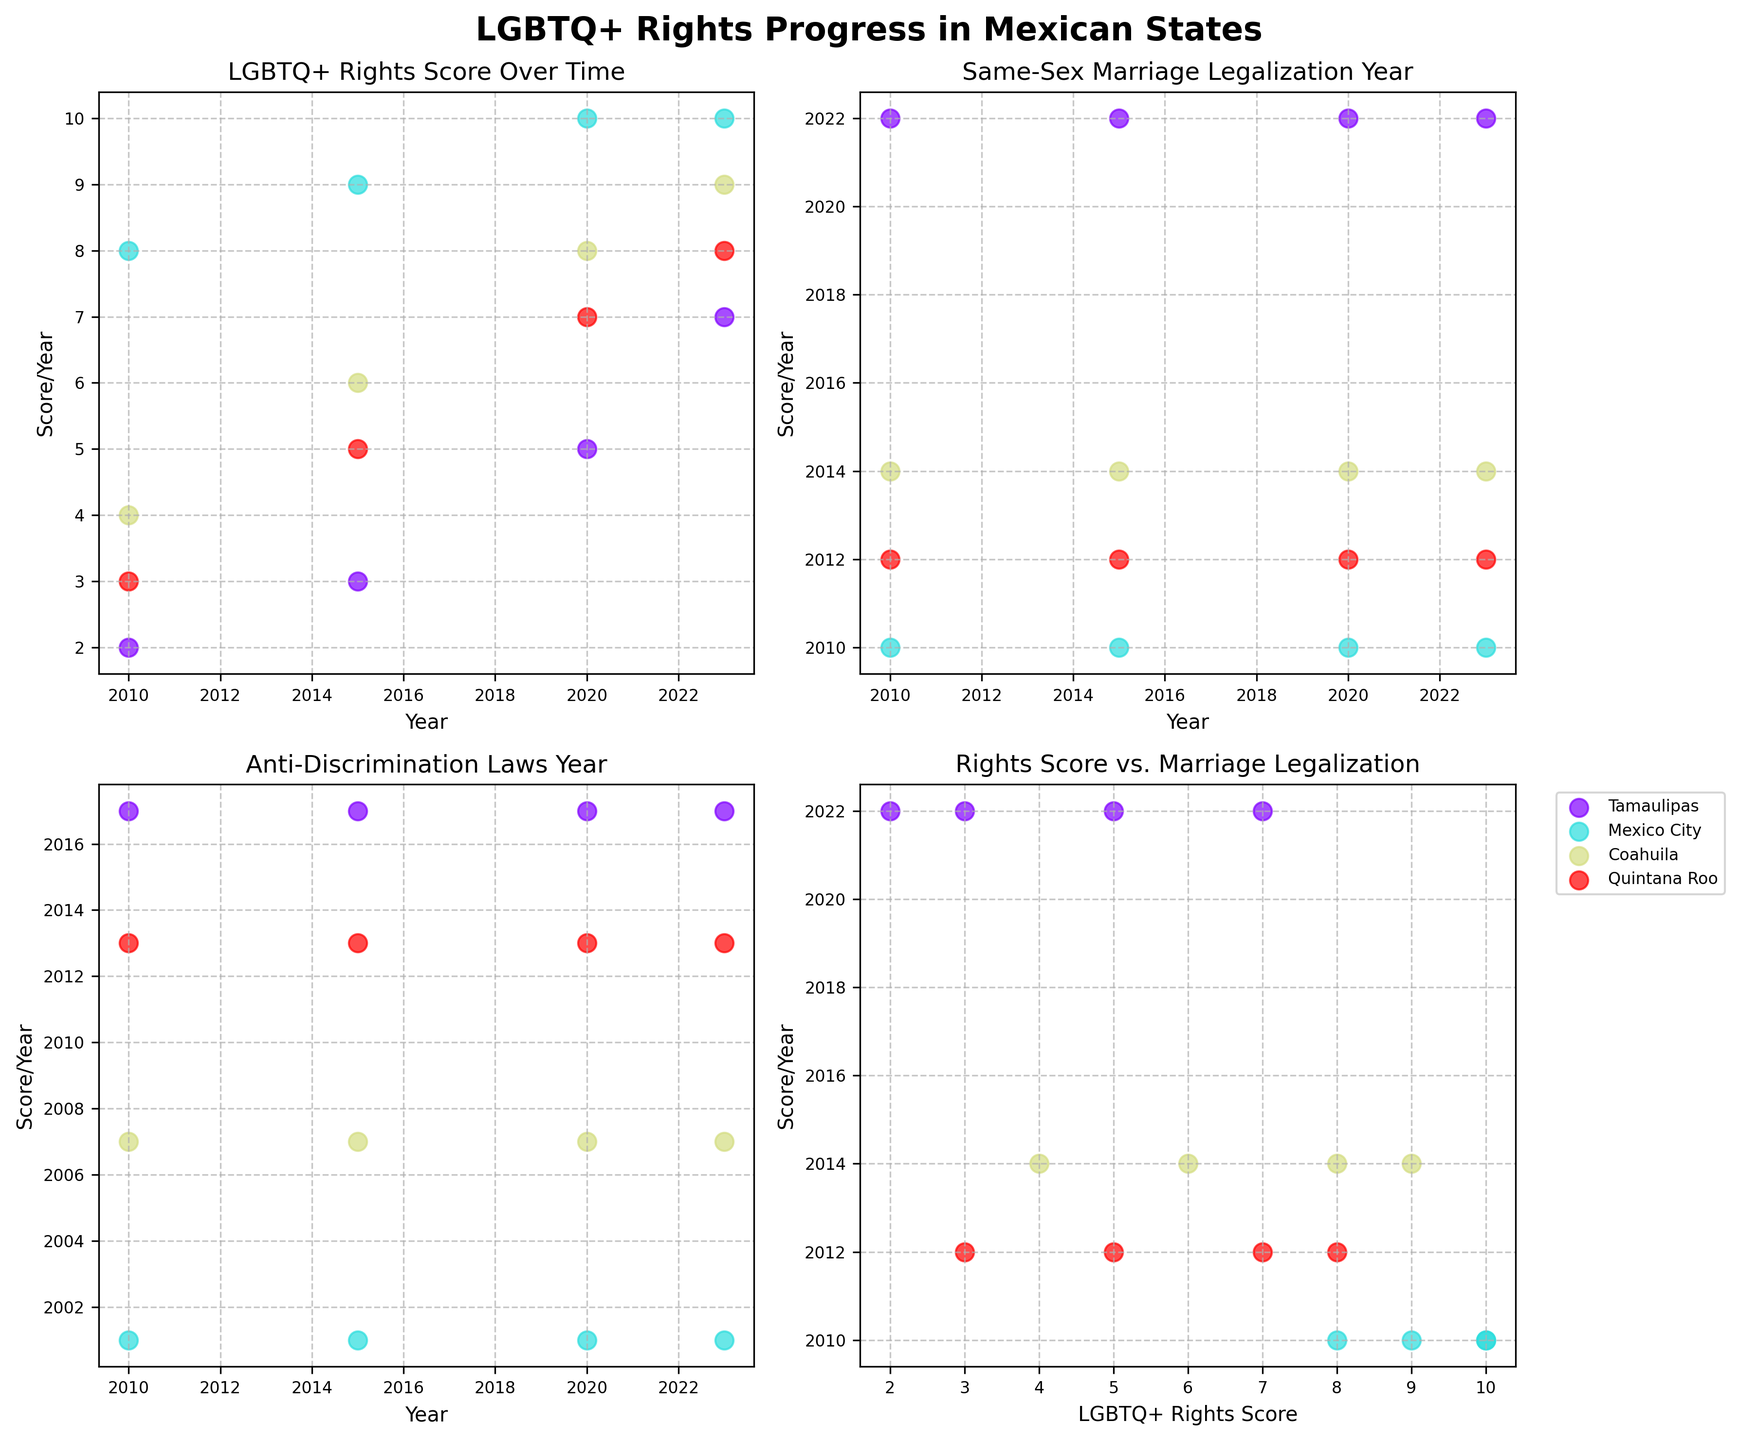What is the title of the figure? The title of the figure is found at the top and gives an overview of what the figure is about.
Answer: LGBTQ+ Rights Progress in Mexican States How many subplots are there in the figure? The figure is divided into smaller plots to showcase different aspects of the data. By counting these, you can find the total number of subplots.
Answer: 4 Which state's LGBTQ+ rights score improved the most between 2010 and 2023? To find this, observe the scores plotted across the years for each state and calculate the difference between 2010 and 2023.
Answer: Tamaulipas What is the trend in Mexico City's LGBTQ+ rights score over time? By looking at the scatter plot points for Mexico City in the relevant subplot, observe whether the score is increasing, decreasing, or remaining constant over time.
Answer: Increasing In which year did Tamaulipas legalize same-sex marriage? This can be determined by observing the corresponding data points in the subplot titled "Same-Sex Marriage Legalization Year."
Answer: 2022 Compare the LGBTQ+ rights scores of Tamaulipas and Coahuila in 2023. Which state has a higher score? Identify the scores for both states in the subplot for 2023 and compare them directly.
Answer: Coahuila What general pattern can be observed in the subplot titled "Anti-Discrimination Laws Year"? By looking at this subplot, determine if the plotted points show specific trends such as clustering or dispersing over certain years.
Answer: Clustering around specific years for different states How does Quintana Roo's same-sex marriage legalization year compare to Mexico City's? Compare the corresponding data points for both states in the subplot titled "Same-Sex Marriage Legalization Year."
Answer: Later than Mexico City Which state had the earliest anti-discrimination laws? By examining the earliest year in the subplot for anti-discrimination laws for each state, you can determine which state implemented these laws first.
Answer: Mexico City How does the rights score for Coahuila correlate with the year same-sex marriage was legalized there? Look at the subplot showing "Rights Score vs. Marriage Legalization" and identify the plotted points for Coahuila to examine the relationship.
Answer: Higher rights score after legalization 